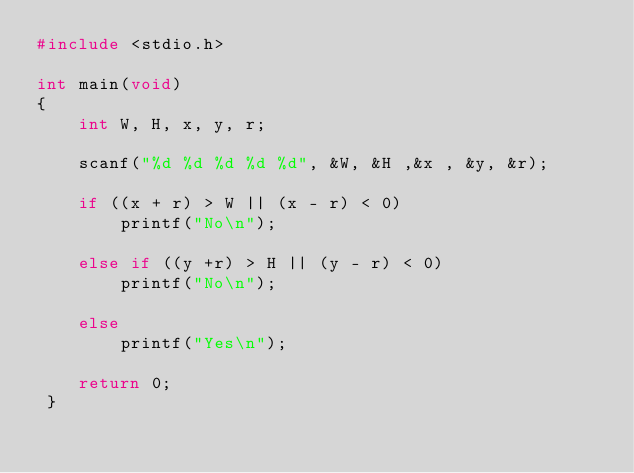Convert code to text. <code><loc_0><loc_0><loc_500><loc_500><_C_>#include <stdio.h>

int main(void)
{
    int W, H, x, y, r;

    scanf("%d %d %d %d %d", &W, &H ,&x , &y, &r);

    if ((x + r) > W || (x - r) < 0)
        printf("No\n");

    else if ((y +r) > H || (y - r) < 0)
        printf("No\n"); 

    else 
        printf("Yes\n");

    return 0;
 }
</code> 